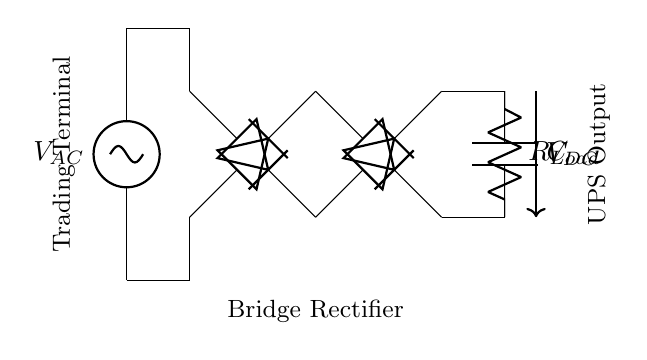What is the type of rectifier used in this circuit? The circuit is a bridge rectifier, which consists of four diodes arranged in a bridge configuration to convert alternating current to direct current.
Answer: bridge rectifier What is the function of the capacitor in this circuit? The capacitor smooths the output voltage by filtering out the ripples from the rectified AC signal, thus providing a more stable DC output for the load.
Answer: smoothing What is the load in the circuit? The load is represented by the resistor labeled as R Load, which consumes the power supplied by the rectifier and capacitor.
Answer: R Load How many diodes are present in the bridge rectifier? There are four diodes used in the bridge rectifier to allow current to flow in both directions during each half of the AC cycle.
Answer: four What is the output voltage direction in this circuit? The output voltage, denoted as V DC, flows from the positive output terminal to the negative output terminal, indicating the direction of current flow in the DC output.
Answer: from positive to negative Which component is responsible for voltage regulation? The smoothing capacitor is responsible for maintaining a stable DC voltage by reducing voltage fluctuations caused by the rectification process.
Answer: capacitor 